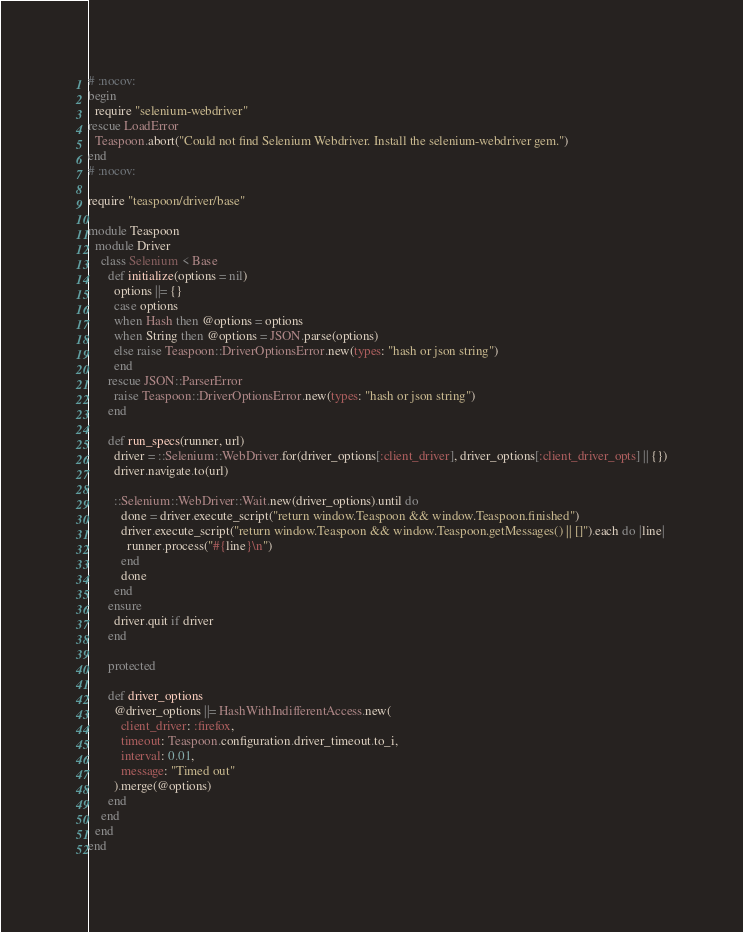Convert code to text. <code><loc_0><loc_0><loc_500><loc_500><_Ruby_># :nocov:
begin
  require "selenium-webdriver"
rescue LoadError
  Teaspoon.abort("Could not find Selenium Webdriver. Install the selenium-webdriver gem.")
end
# :nocov:

require "teaspoon/driver/base"

module Teaspoon
  module Driver
    class Selenium < Base
      def initialize(options = nil)
        options ||= {}
        case options
        when Hash then @options = options
        when String then @options = JSON.parse(options)
        else raise Teaspoon::DriverOptionsError.new(types: "hash or json string")
        end
      rescue JSON::ParserError
        raise Teaspoon::DriverOptionsError.new(types: "hash or json string")
      end

      def run_specs(runner, url)
        driver = ::Selenium::WebDriver.for(driver_options[:client_driver], driver_options[:client_driver_opts] || {})
        driver.navigate.to(url)

        ::Selenium::WebDriver::Wait.new(driver_options).until do
          done = driver.execute_script("return window.Teaspoon && window.Teaspoon.finished")
          driver.execute_script("return window.Teaspoon && window.Teaspoon.getMessages() || []").each do |line|
            runner.process("#{line}\n")
          end
          done
        end
      ensure
        driver.quit if driver
      end

      protected

      def driver_options
        @driver_options ||= HashWithIndifferentAccess.new(
          client_driver: :firefox,
          timeout: Teaspoon.configuration.driver_timeout.to_i,
          interval: 0.01,
          message: "Timed out"
        ).merge(@options)
      end
    end
  end
end
</code> 